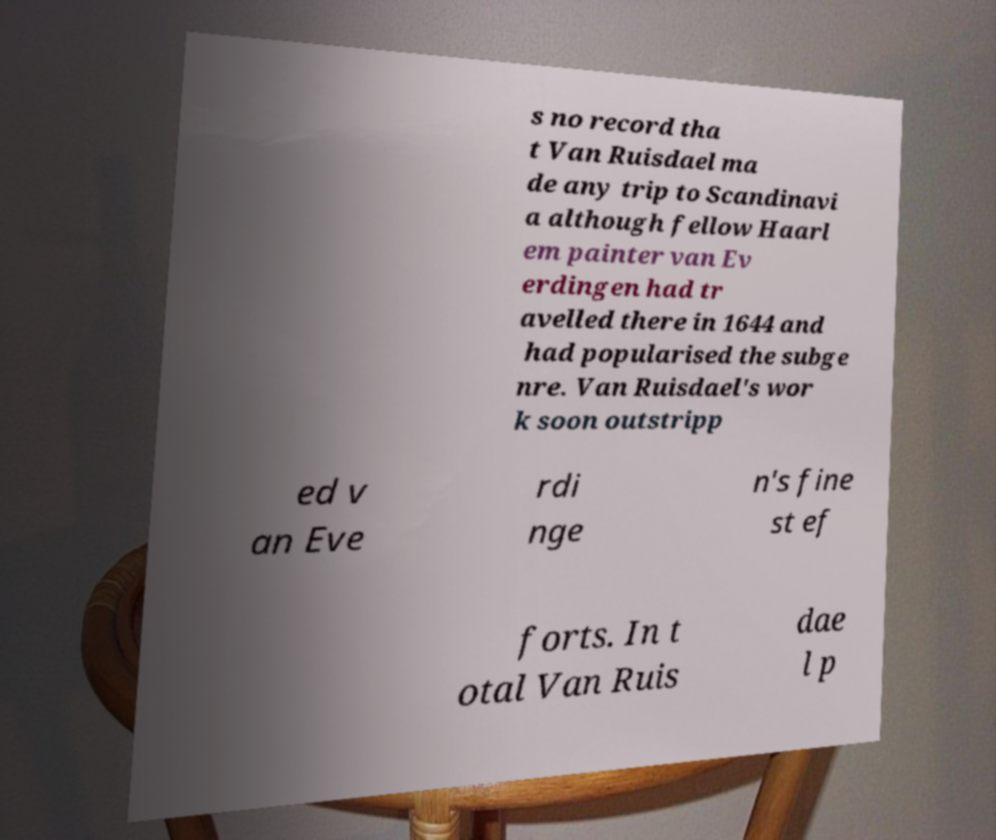Can you read and provide the text displayed in the image?This photo seems to have some interesting text. Can you extract and type it out for me? s no record tha t Van Ruisdael ma de any trip to Scandinavi a although fellow Haarl em painter van Ev erdingen had tr avelled there in 1644 and had popularised the subge nre. Van Ruisdael's wor k soon outstripp ed v an Eve rdi nge n's fine st ef forts. In t otal Van Ruis dae l p 